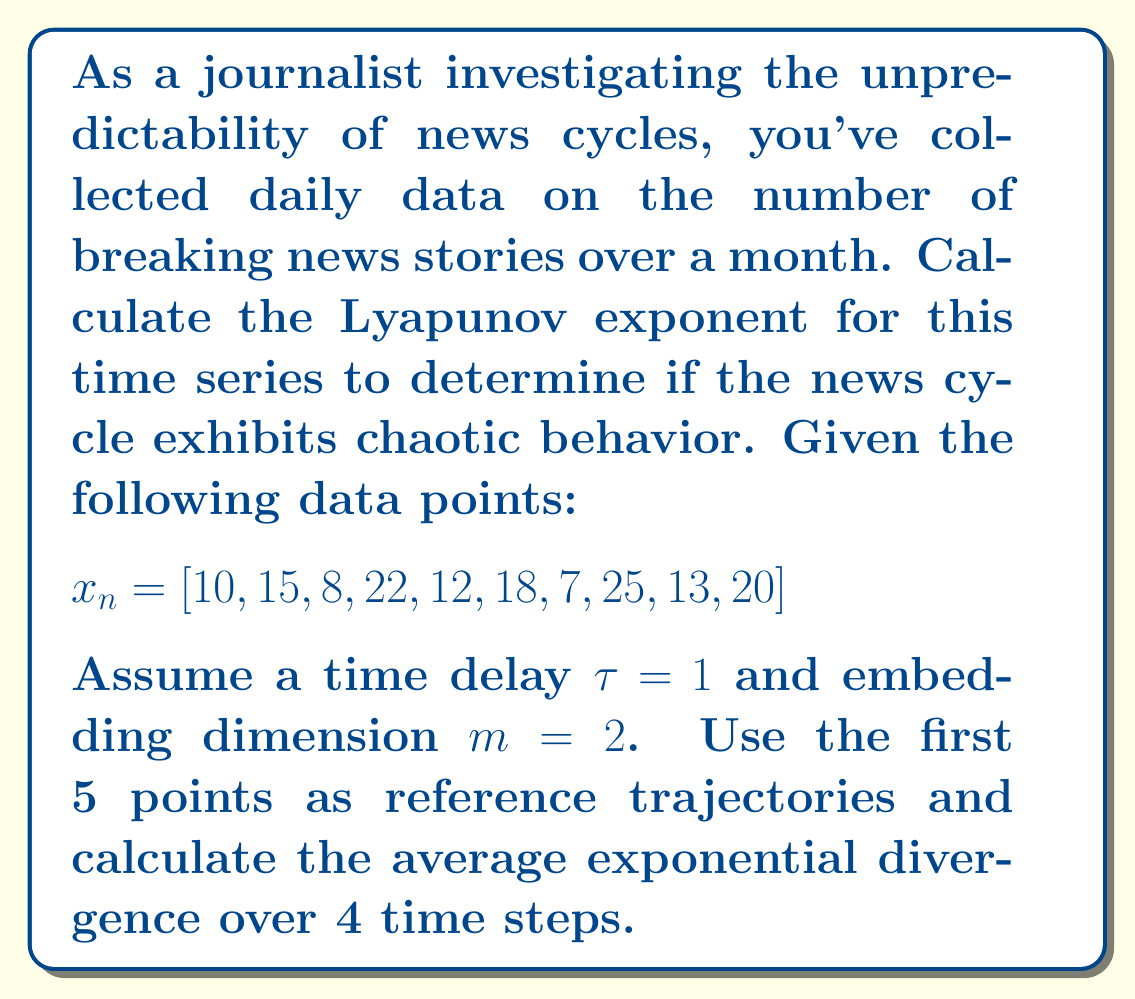Teach me how to tackle this problem. To calculate the Lyapunov exponent for this time series:

1. Construct the phase space vectors:
   $$\vec{x_1} = (10, 15), \vec{x_2} = (15, 8), \vec{x_3} = (8, 22), \vec{x_4} = (22, 12), \vec{x_5} = (12, 18)$$

2. For each reference point, find the nearest neighbor:
   $\vec{x_1}$ nearest to $\vec{x_4}$
   $\vec{x_2}$ nearest to $\vec{x_5}$
   $\vec{x_3}$ nearest to $\vec{x_1}$
   $\vec{x_4}$ nearest to $\vec{x_2}$
   $\vec{x_5}$ nearest to $\vec{x_1}$

3. Calculate the initial distance $d_0$ and final distance $d_n$ after 4 time steps for each pair:
   $d_0(\vec{x_1}, \vec{x_4}) = \sqrt{(10-22)^2 + (15-12)^2} = 12.37$
   $d_4(\vec{x_1}, \vec{x_4}) = \sqrt{(18-20)^2 + (7-13)^2} = 6.32$

   $d_0(\vec{x_2}, \vec{x_5}) = \sqrt{(15-12)^2 + (8-18)^2} = 10.44$
   $d_4(\vec{x_2}, \vec{x_5}) = \sqrt{(20-13)^2 + (13-20)^2} = 9.90$

   $d_0(\vec{x_3}, \vec{x_1}) = \sqrt{(8-10)^2 + (22-15)^2} = 7.28$
   $d_4(\vec{x_3}, \vec{x_1}) = \sqrt{(12-18)^2 + (18-7)^2} = 12.53$

   $d_0(\vec{x_4}, \vec{x_2}) = \sqrt{(22-15)^2 + (12-8)^2} = 8.06$
   $d_4(\vec{x_4}, \vec{x_2}) = \sqrt{(13-20)^2 + (20-13)^2} = 9.90$

   $d_0(\vec{x_5}, \vec{x_1}) = \sqrt{(12-10)^2 + (18-15)^2} = 3.61$
   $d_4(\vec{x_5}, \vec{x_1}) = \sqrt{(13-18)^2 + (20-7)^2} = 13.93$

4. Calculate the Lyapunov exponent for each pair:
   $\lambda_1 = \frac{1}{4} \ln(\frac{6.32}{12.37}) = -0.17$
   $\lambda_2 = \frac{1}{4} \ln(\frac{9.90}{10.44}) = -0.01$
   $\lambda_3 = \frac{1}{4} \ln(\frac{12.53}{7.28}) = 0.14$
   $\lambda_4 = \frac{1}{4} \ln(\frac{9.90}{8.06}) = 0.05$
   $\lambda_5 = \frac{1}{4} \ln(\frac{13.93}{3.61}) = 0.34$

5. Calculate the average Lyapunov exponent:
   $\lambda_{avg} = \frac{-0.17 + (-0.01) + 0.14 + 0.05 + 0.34}{5} = 0.07$

The positive Lyapunov exponent indicates chaotic behavior in the news cycle.
Answer: $\lambda_{avg} = 0.07$ 